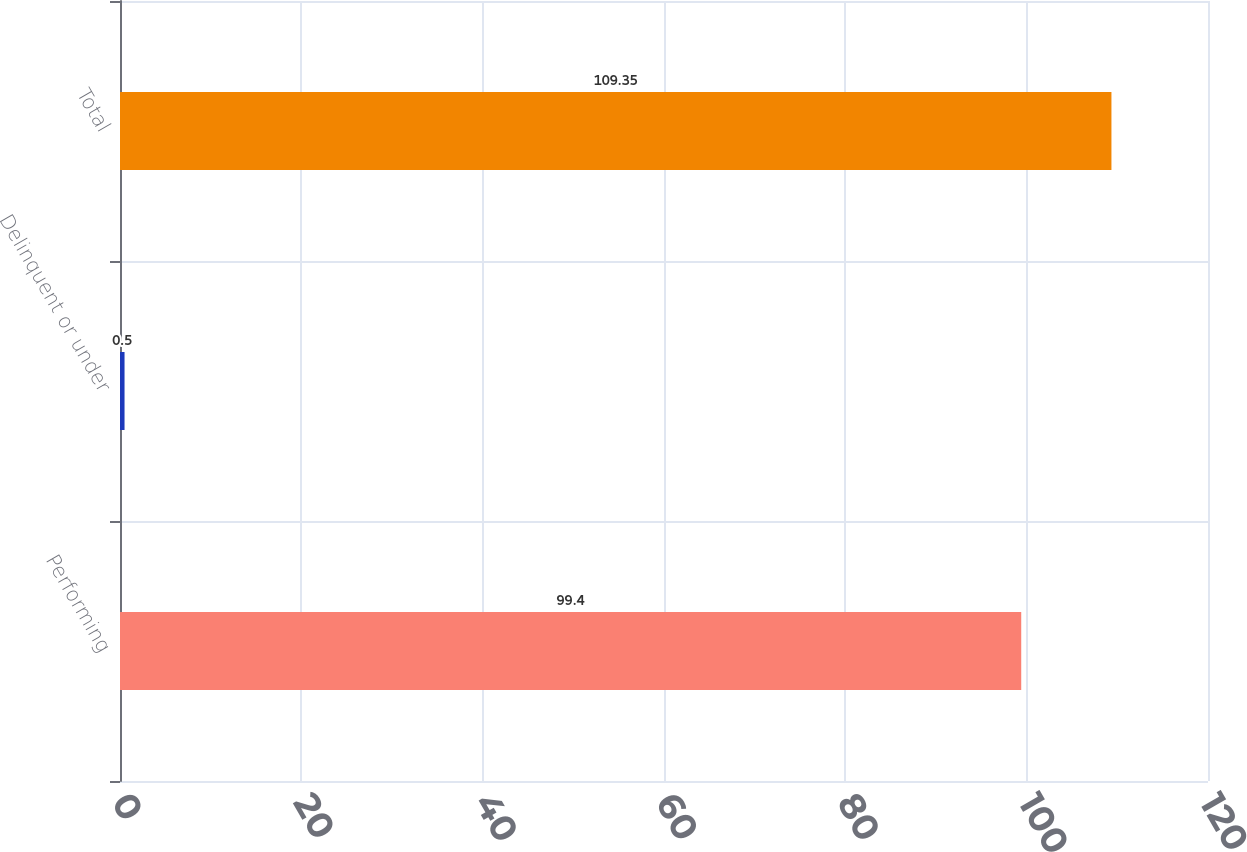<chart> <loc_0><loc_0><loc_500><loc_500><bar_chart><fcel>Performing<fcel>Delinquent or under<fcel>Total<nl><fcel>99.4<fcel>0.5<fcel>109.35<nl></chart> 